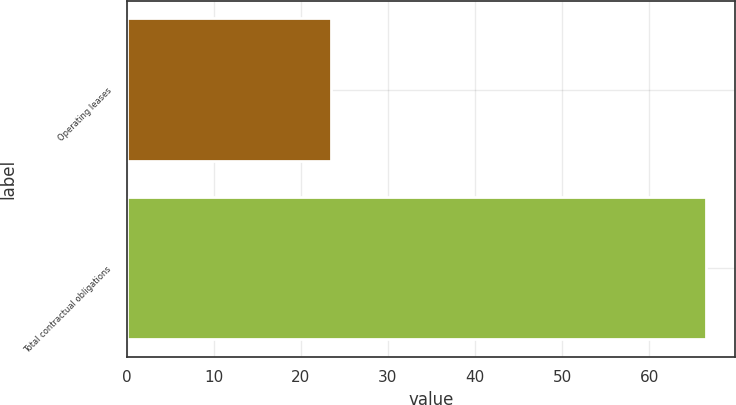Convert chart to OTSL. <chart><loc_0><loc_0><loc_500><loc_500><bar_chart><fcel>Operating leases<fcel>Total contractual obligations<nl><fcel>23.5<fcel>66.5<nl></chart> 